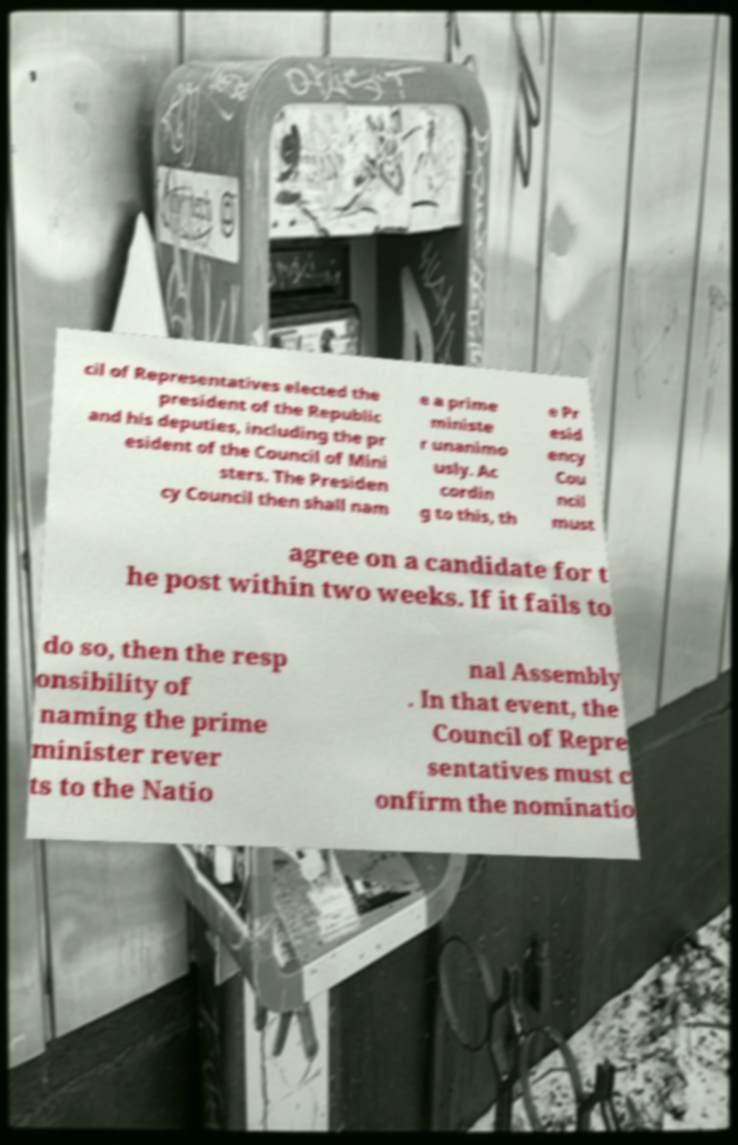Can you accurately transcribe the text from the provided image for me? cil of Representatives elected the president of the Republic and his deputies, including the pr esident of the Council of Mini sters. The Presiden cy Council then shall nam e a prime ministe r unanimo usly. Ac cordin g to this, th e Pr esid ency Cou ncil must agree on a candidate for t he post within two weeks. If it fails to do so, then the resp onsibility of naming the prime minister rever ts to the Natio nal Assembly . In that event, the Council of Repre sentatives must c onfirm the nominatio 